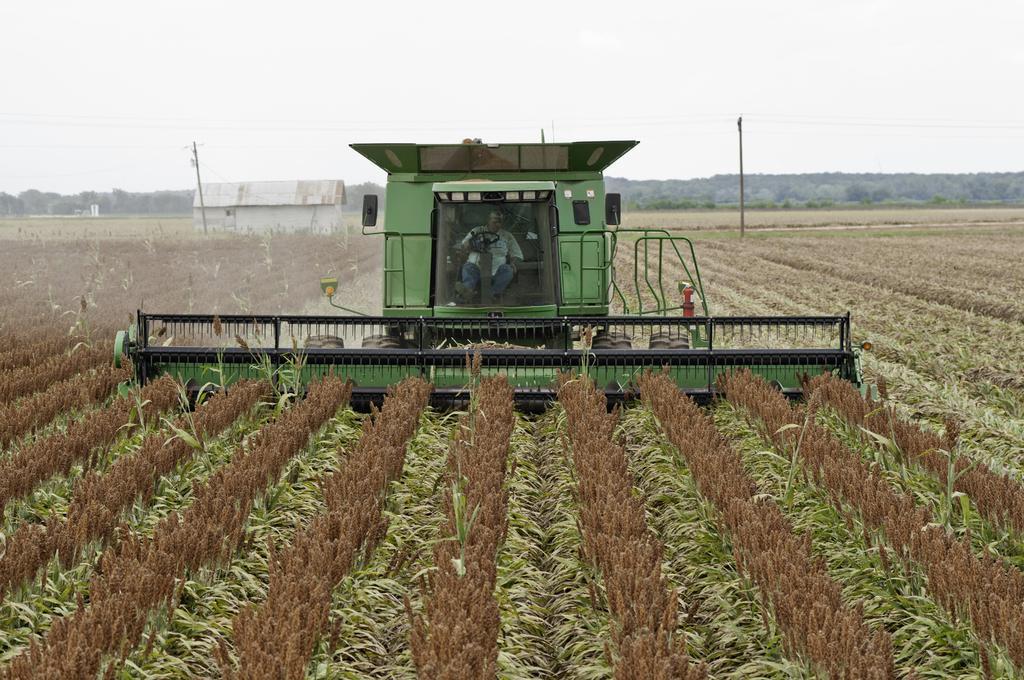Please provide a concise description of this image. In this image, we can see a person is riding a tractor in the field. Here we can see plants. Background there are few poles, shelter, trees and sky. 